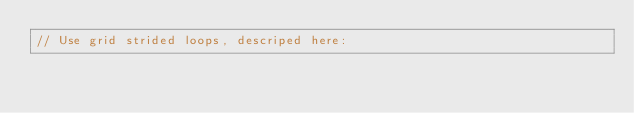Convert code to text. <code><loc_0><loc_0><loc_500><loc_500><_Cuda_>// Use grid strided loops, descriped here:</code> 